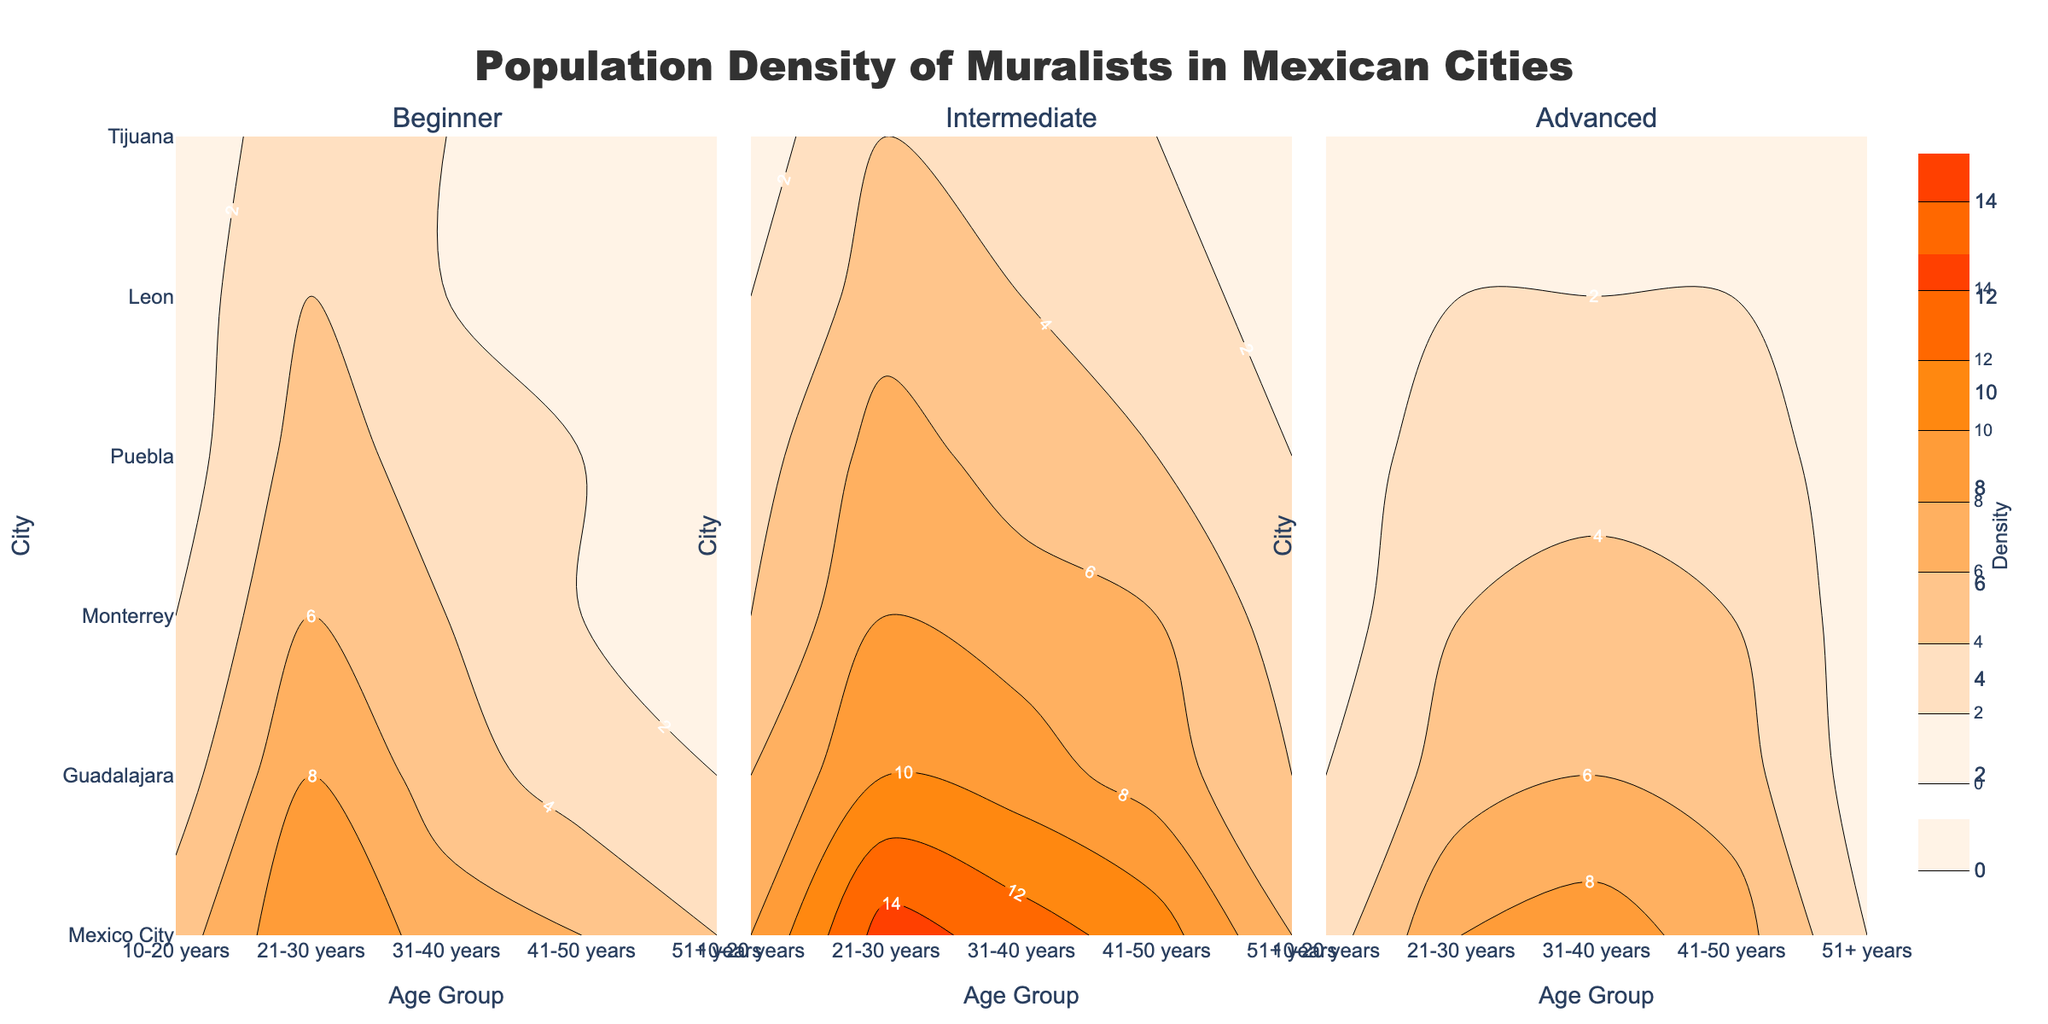What is the title of the figure? The title of the figure appears at the top and reads "Population Density of Muralists in Mexican Cities". This provides a quick overview of what the figure represents.
Answer: Population Density of Muralists in Mexican Cities Which city has the highest density of 21-30 years (Intermediate) muralists? Locate the age group "21-30 years" and "Intermediate" experience level. Then identify the city with the highest density from the corresponding color intensity or contour labels in the middle column.
Answer: Mexico City How does the density of 31-40 years (Advanced) muralists in Leon compare to Mexico City? Compare the contour lines or labels for "31-40 years" and "Advanced" level across both cities. Mexico City shows higher density values compared to Leon, which has much lower values.
Answer: Mexico City has a higher density What is the trend of population density across different cities for 41-50 years (Beginner)? Observe the contours or labels for "41-50 years (Beginner)" across the different cities. The density starts higher in Mexico City and decreases as we move to smaller cities like Tijuana.
Answer: Decreasing trend Which age group and experience level combination has the lowest density in Tijuana? Look at the population density across all age groups and experience levels for Tijuana. The values for "10-20 years (Advanced)" and "41-50 years (Beginner)" are particularly low.
Answer: 10-20 years (Advanced) What is the general pattern observed for intermediate level muralists across all age groups and cities? By scanning the middle column showing the "Intermediate" level, you can identify that Mexico City consistently has higher densities than other cities, with a gradually decreasing density pattern as the cities get smaller.
Answer: Higher in Mexico City, decreasing in smaller cities Compare the density of 51+ years (Advanced) muralists in Guadalajara and Monterrey. Look at the age group "51+ years" and "Advanced" level for both cities. Both cities have very low densities, but Monterrey appears to have a slightly higher value than Guadalajara.
Answer: Monterrey has a slightly higher density How does the contour color change as density increases for any given city and experience level? Observe the color gradient in the contour plots. The color changes from light shades for lower densities to darker shades for higher densities, such as from light peach to deep orange.
Answer: Light to dark Which age group has the highest density in Puebla for intermediate level muralists? Look at the contours or labels within the "Intermediate" level column for Puebla. The "21-30 years" age group shows the highest density.
Answer: 21-30 years In what age group does Leon have the highest density of beginner muralists? Examine the "Beginner" experience level row for Leon. The "21-30 years" age group shows the highest density among all the provided age groups.
Answer: 21-30 years 